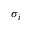Convert formula to latex. <formula><loc_0><loc_0><loc_500><loc_500>\sigma _ { i }</formula> 